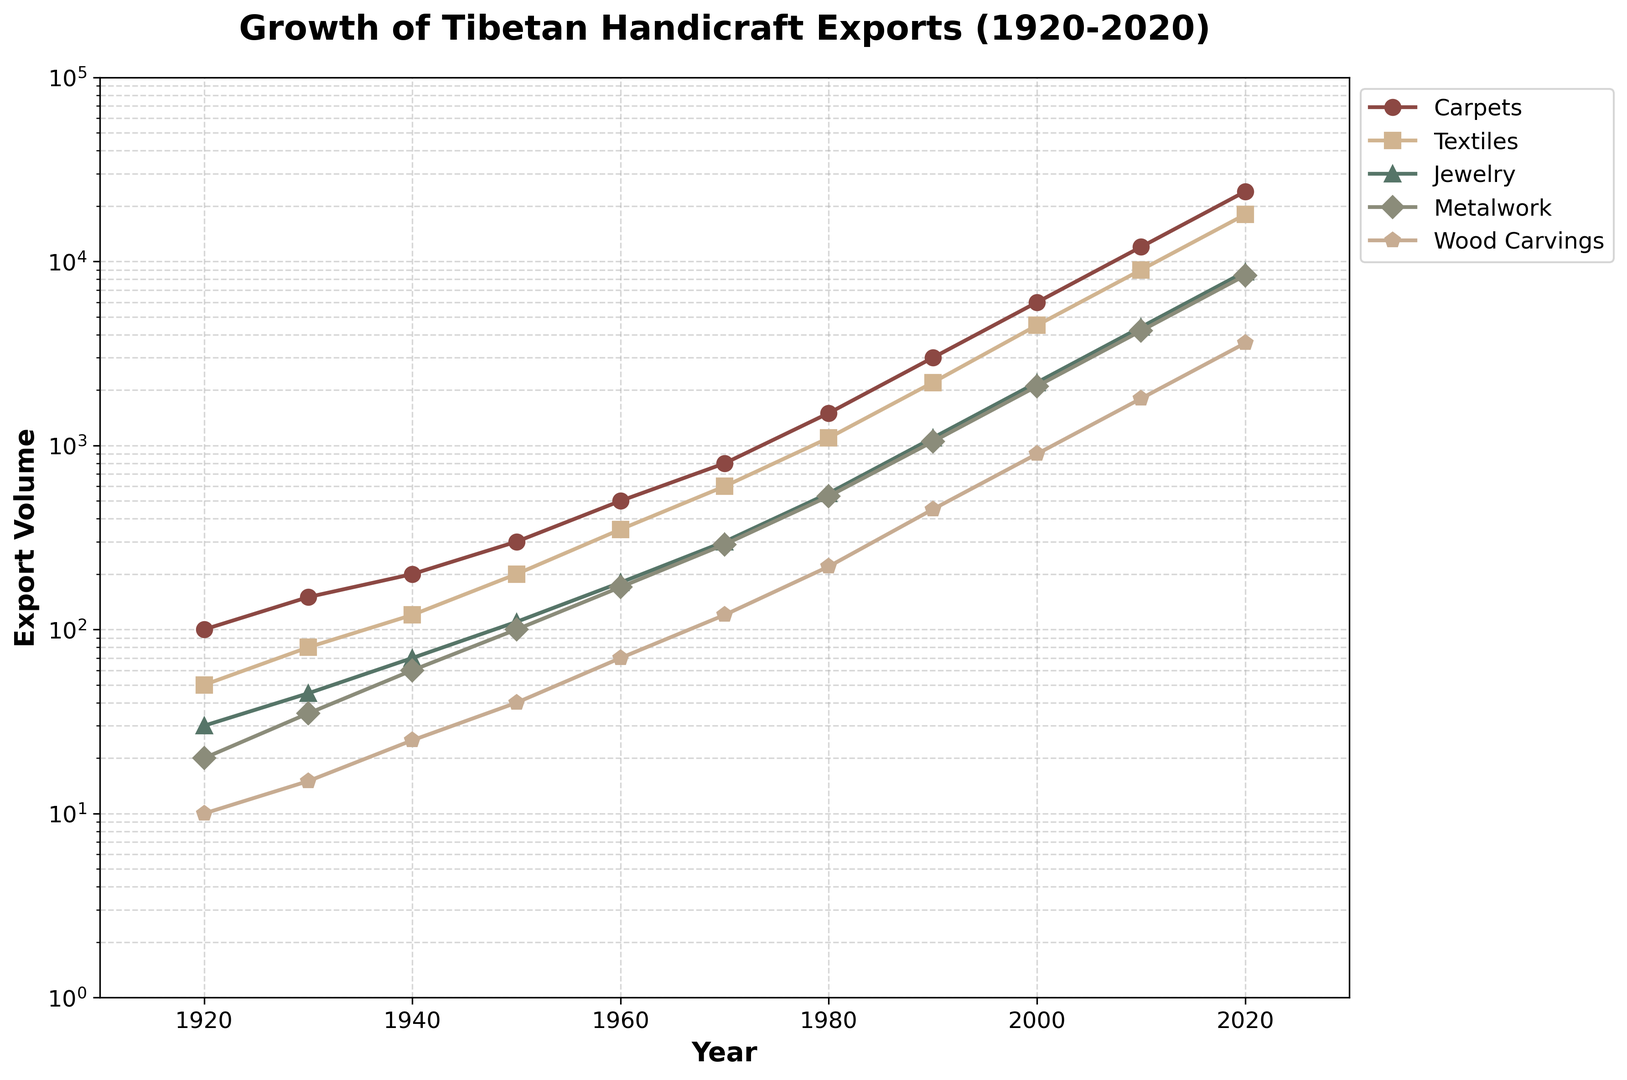What year did the export volume of Carpets first exceed 10,000? The exponential growth of Carpets' export volume shows that it reached 12,000 in 2010. The year prior, in 2000, the volume was 6,000. Therefore, the first year it exceeded 10,000 is 2010.
Answer: 2010 Which product type experienced the smallest growth in exports from 1920 to 2020? By comparing the initial and final values of each product type on the logarithmic scale, Metalwork shows a growth from 20 to 8,400, which is smaller compared to Carpets (100 to 24,000) and others. Therefore, Metalwork has the smallest growth.
Answer: Metalwork What is the median export volume of Textiles in the data provided? To find the median, list the export volumes of Textiles: 50, 80, 120, 200, 350, 600, 1,100, 2,200, 4,500, 9,000, 18,000. The middle value of this ordered list, with 11 data points, is the sixth value, which is 600.
Answer: 600 Between which consecutive decades did Wood Carvings see its largest relative growth? To find this, calculate the relative growth between each consecutive decade, and compare their values:
     1920-1930: (15-10)/10 = 0.5
     1930-1940: (25-15)/15 = 0.67
     1940-1950: (40-25)/25 = 0.6
     1950-1960: (70-40)/40 = 0.75
     1960-1970: (120-70)/70 = 0.71
     1970-1980: (220-120)/120 = 0.83
     1980-1990: (450-220)/220 = 1.045
     1990-2000: (900-450)/450 = 1.0
     2000-2010: (1,800-900)/900 = 1.0
     2010-2020: (3,600-1,800)/1,800 = 1.0
The largest relative growth occurred between 1980 and 1990, with a growth rate of approximately 1.045.
Answer: 1980-1990 What product type consistently has the second highest export volume from 1920 to 2020? By visually comparing the different export volumes over the years, Textiles consistently hold the second highest export volume throughout the given years, following Carpets.
Answer: Textiles At what points do the export volumes of Jewelry and Metalwork become equal? By examining the plot, Jewelry and Metalwork exports intersect around 2000, where both have approximately similar export volumes.
Answer: Around 2000 In which year was the export volume of Wood Carvings the same as Textiles in 1980? Comparing the values, Textiles had 1,100 in 1980. The export volume of Wood Carvings reaches approximately this value between 1990 and 2000. During this period, Wood Carvings is about 900 in 2000, so it's closest at 2000.
Answer: 2000 Which product showed the highest export volume increase from 1980 to 2010? By calculating the difference between the export volumes in 1980 and 2010:
     Carpets: 12,000 - 1,500 = 10,500
     Textiles: 9,000 - 1,100 = 7,900
     Jewelry: 4,400 - 550 = 3,850
     Metalwork: 4,200 - 530 = 3,670
     Wood Carvings: 1,800 - 220 = 1,580
Carpets had the highest increase of 10,500.
Answer: Carpets 